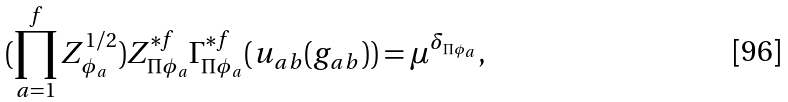<formula> <loc_0><loc_0><loc_500><loc_500>( \prod _ { a = 1 } ^ { f } Z _ { \phi _ { a } } ^ { 1 / 2 } ) Z ^ { * f } _ { \Pi \phi _ { a } } \Gamma ^ { * f } _ { \Pi \phi _ { a } } ( u _ { a b } ( g _ { a b } ) ) = \mu ^ { \delta _ { \Pi \phi _ { a } } } ,</formula> 